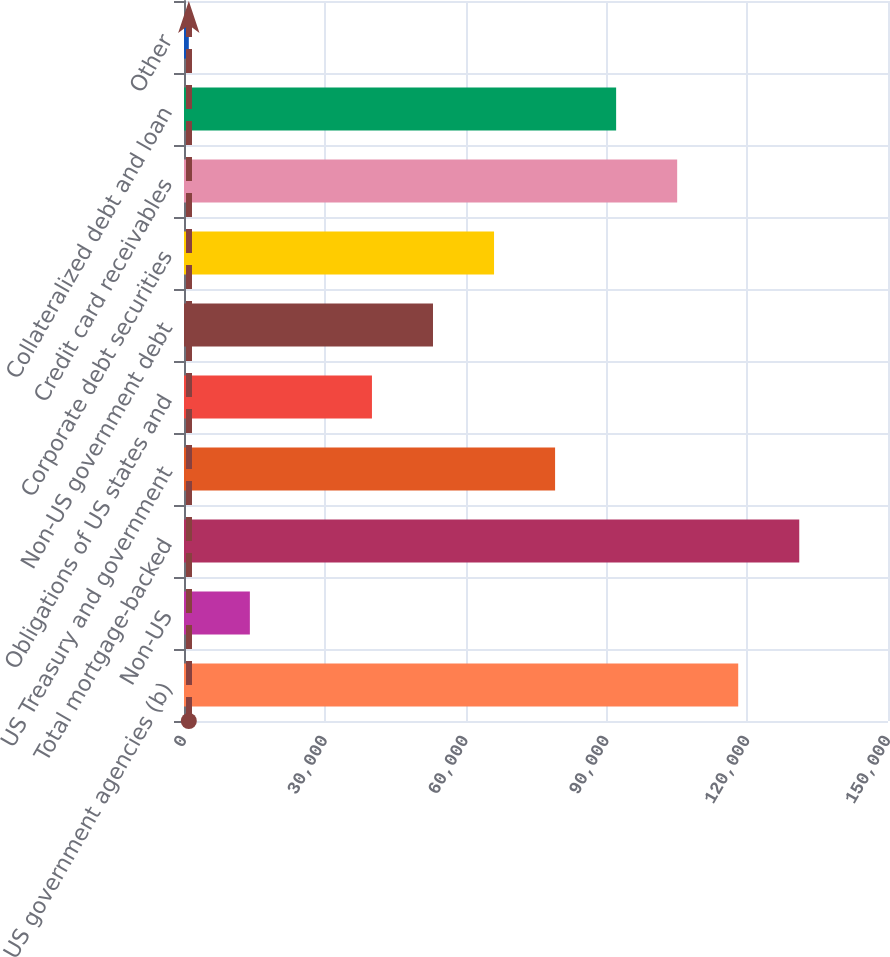Convert chart. <chart><loc_0><loc_0><loc_500><loc_500><bar_chart><fcel>US government agencies (b)<fcel>Non-US<fcel>Total mortgage-backed<fcel>US Treasury and government<fcel>Obligations of US states and<fcel>Non-US government debt<fcel>Corporate debt securities<fcel>Credit card receivables<fcel>Collateralized debt and loan<fcel>Other<nl><fcel>118086<fcel>14032.7<fcel>131093<fcel>79066.2<fcel>40046.1<fcel>53052.8<fcel>66059.5<fcel>105080<fcel>92072.9<fcel>1026<nl></chart> 